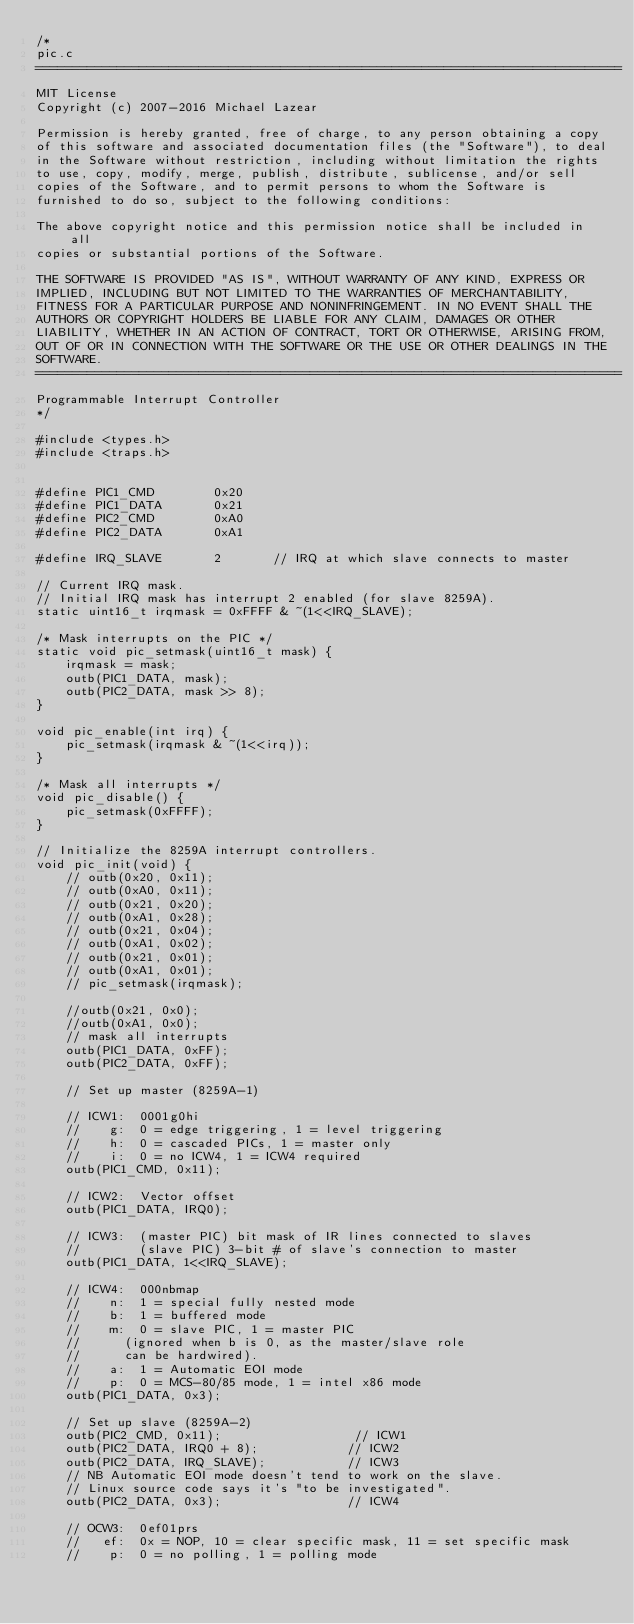Convert code to text. <code><loc_0><loc_0><loc_500><loc_500><_C_>/*
pic.c
===============================================================================
MIT License
Copyright (c) 2007-2016 Michael Lazear

Permission is hereby granted, free of charge, to any person obtaining a copy
of this software and associated documentation files (the "Software"), to deal
in the Software without restriction, including without limitation the rights
to use, copy, modify, merge, publish, distribute, sublicense, and/or sell
copies of the Software, and to permit persons to whom the Software is
furnished to do so, subject to the following conditions:

The above copyright notice and this permission notice shall be included in all
copies or substantial portions of the Software.

THE SOFTWARE IS PROVIDED "AS IS", WITHOUT WARRANTY OF ANY KIND, EXPRESS OR
IMPLIED, INCLUDING BUT NOT LIMITED TO THE WARRANTIES OF MERCHANTABILITY,
FITNESS FOR A PARTICULAR PURPOSE AND NONINFRINGEMENT. IN NO EVENT SHALL THE
AUTHORS OR COPYRIGHT HOLDERS BE LIABLE FOR ANY CLAIM, DAMAGES OR OTHER
LIABILITY, WHETHER IN AN ACTION OF CONTRACT, TORT OR OTHERWISE, ARISING FROM,
OUT OF OR IN CONNECTION WITH THE SOFTWARE OR THE USE OR OTHER DEALINGS IN THE
SOFTWARE.
===============================================================================
Programmable Interrupt Controller
*/

#include <types.h>
#include <traps.h>


#define PIC1_CMD		0x20
#define PIC1_DATA		0x21
#define PIC2_CMD		0xA0
#define PIC2_DATA		0xA1

#define IRQ_SLAVE       2       // IRQ at which slave connects to master

// Current IRQ mask.
// Initial IRQ mask has interrupt 2 enabled (for slave 8259A).
static uint16_t irqmask = 0xFFFF & ~(1<<IRQ_SLAVE);

/* Mask interrupts on the PIC */
static void pic_setmask(uint16_t mask) {
	irqmask = mask;
	outb(PIC1_DATA, mask);
	outb(PIC2_DATA, mask >> 8);
}

void pic_enable(int irq) {
 	pic_setmask(irqmask & ~(1<<irq));
}

/* Mask all interrupts */
void pic_disable() {
	pic_setmask(0xFFFF);
}

// Initialize the 8259A interrupt controllers.
void pic_init(void) {
	// outb(0x20, 0x11);
	// outb(0xA0, 0x11);
	// outb(0x21, 0x20);
	// outb(0xA1, 0x28);
	// outb(0x21, 0x04);
	// outb(0xA1, 0x02);
	// outb(0x21, 0x01);
	// outb(0xA1, 0x01);
	// pic_setmask(irqmask);

	//outb(0x21, 0x0);
	//outb(0xA1, 0x0);
	// mask all interrupts
	outb(PIC1_DATA, 0xFF);
	outb(PIC2_DATA, 0xFF);

	// Set up master (8259A-1)

	// ICW1:  0001g0hi
	//    g:  0 = edge triggering, 1 = level triggering
	//    h:  0 = cascaded PICs, 1 = master only
	//    i:  0 = no ICW4, 1 = ICW4 required
	outb(PIC1_CMD, 0x11);

	// ICW2:  Vector offset
	outb(PIC1_DATA, IRQ0);

	// ICW3:  (master PIC) bit mask of IR lines connected to slaves
	//        (slave PIC) 3-bit # of slave's connection to master
	outb(PIC1_DATA, 1<<IRQ_SLAVE);

	// ICW4:  000nbmap
	//    n:  1 = special fully nested mode
	//    b:  1 = buffered mode
	//    m:  0 = slave PIC, 1 = master PIC
	//      (ignored when b is 0, as the master/slave role
	//      can be hardwired).
	//    a:  1 = Automatic EOI mode
	//    p:  0 = MCS-80/85 mode, 1 = intel x86 mode
	outb(PIC1_DATA, 0x3);

	// Set up slave (8259A-2)
	outb(PIC2_CMD, 0x11);                  // ICW1
	outb(PIC2_DATA, IRQ0 + 8);            // ICW2
	outb(PIC2_DATA, IRQ_SLAVE);           // ICW3
	// NB Automatic EOI mode doesn't tend to work on the slave.
	// Linux source code says it's "to be investigated".
	outb(PIC2_DATA, 0x3);                 // ICW4

	// OCW3:  0ef01prs
	//   ef:  0x = NOP, 10 = clear specific mask, 11 = set specific mask
	//    p:  0 = no polling, 1 = polling mode</code> 